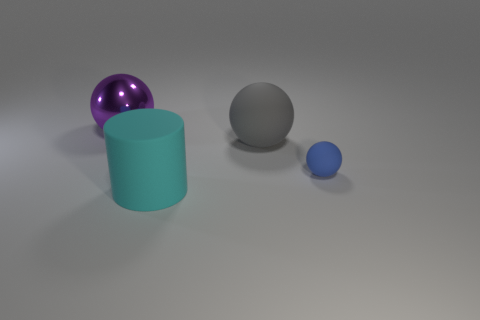What number of cylinders are tiny blue things or large matte objects?
Offer a very short reply. 1. What is the size of the thing that is in front of the rubber object right of the large ball that is in front of the purple metallic thing?
Your answer should be compact. Large. The cyan thing that is the same size as the metal sphere is what shape?
Your answer should be very brief. Cylinder. What shape is the cyan matte thing?
Ensure brevity in your answer.  Cylinder. Does the big sphere on the right side of the rubber cylinder have the same material as the small object?
Make the answer very short. Yes. There is a matte object that is left of the big ball in front of the big purple thing; what is its size?
Offer a very short reply. Large. There is a object that is both in front of the big matte sphere and to the left of the small thing; what color is it?
Your response must be concise. Cyan. There is a cyan object that is the same size as the gray matte sphere; what is its material?
Offer a terse response. Rubber. How many other objects are there of the same material as the cylinder?
Keep it short and to the point. 2. What shape is the small blue thing in front of the big rubber object that is to the right of the big cylinder?
Give a very brief answer. Sphere. 